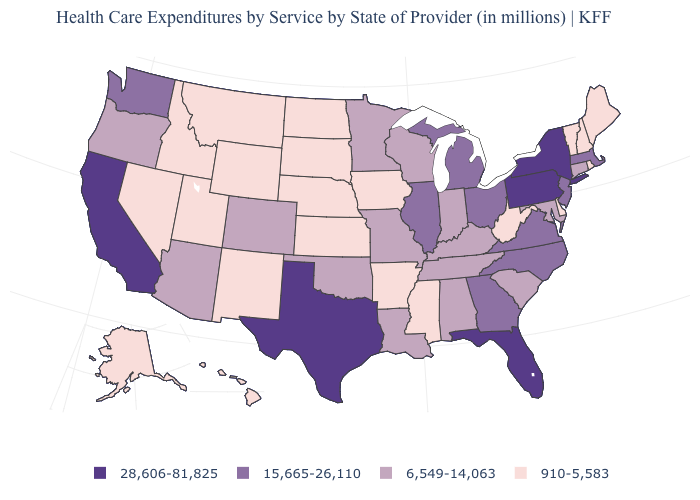Is the legend a continuous bar?
Write a very short answer. No. What is the value of New Hampshire?
Short answer required. 910-5,583. Does Oregon have the lowest value in the West?
Give a very brief answer. No. Among the states that border Iowa , does Wisconsin have the lowest value?
Short answer required. No. Among the states that border Maryland , does West Virginia have the lowest value?
Write a very short answer. Yes. What is the value of Missouri?
Quick response, please. 6,549-14,063. Does Delaware have the lowest value in the USA?
Write a very short answer. Yes. Name the states that have a value in the range 28,606-81,825?
Concise answer only. California, Florida, New York, Pennsylvania, Texas. Name the states that have a value in the range 15,665-26,110?
Answer briefly. Georgia, Illinois, Massachusetts, Michigan, New Jersey, North Carolina, Ohio, Virginia, Washington. Does New Mexico have a higher value than Wisconsin?
Quick response, please. No. Does Ohio have the highest value in the MidWest?
Give a very brief answer. Yes. What is the value of Georgia?
Keep it brief. 15,665-26,110. What is the lowest value in the USA?
Short answer required. 910-5,583. What is the value of Minnesota?
Quick response, please. 6,549-14,063. 